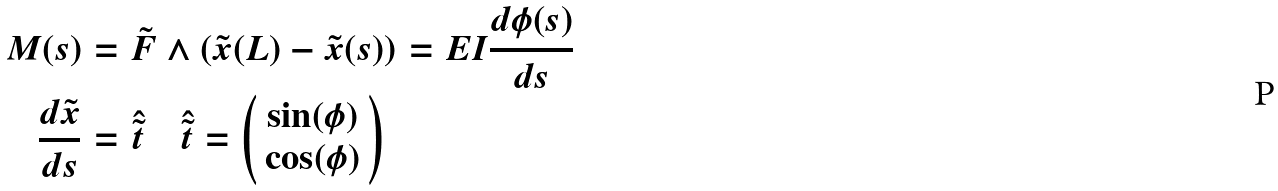<formula> <loc_0><loc_0><loc_500><loc_500>M ( s ) & = \tilde { F } \wedge ( \tilde { x } ( L ) - \tilde { x } ( s ) ) = E I \frac { d \phi ( s ) } { d s } \\ \frac { d \tilde { x } } { d s } & = \hat { \tilde { t } } \quad \hat { \tilde { t } } = \left ( \begin{array} { c } \sin ( \phi ) \\ \cos ( \phi ) \end{array} \right )</formula> 